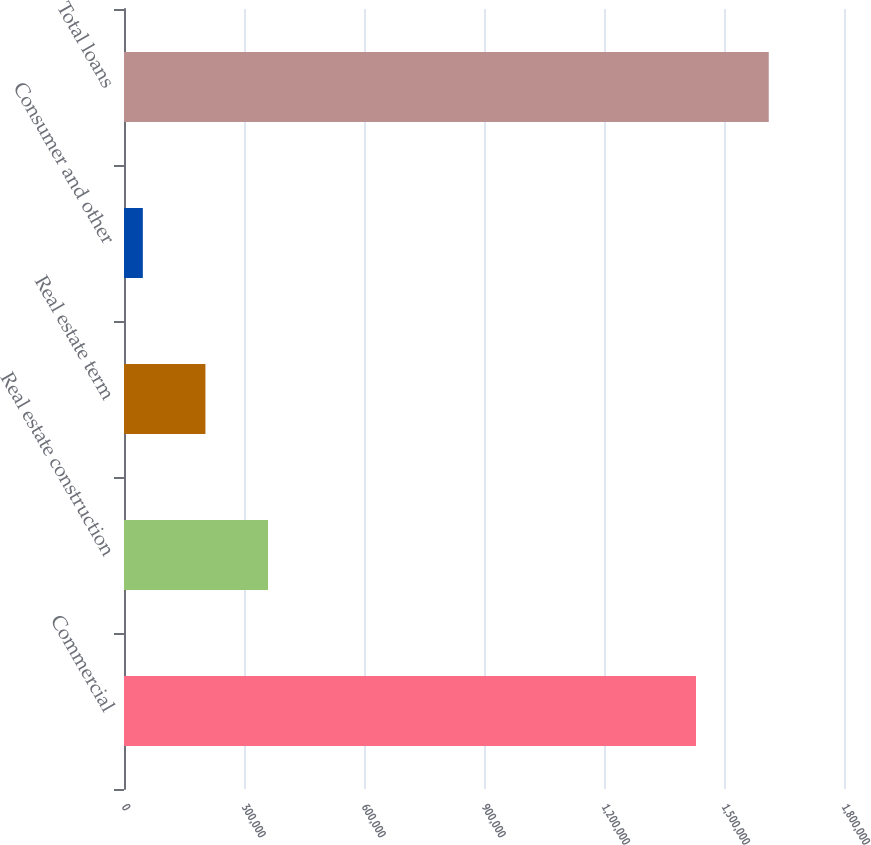Convert chart. <chart><loc_0><loc_0><loc_500><loc_500><bar_chart><fcel>Commercial<fcel>Real estate construction<fcel>Real estate term<fcel>Consumer and other<fcel>Total loans<nl><fcel>1.42998e+06<fcel>360046<fcel>203561<fcel>47077<fcel>1.61192e+06<nl></chart> 